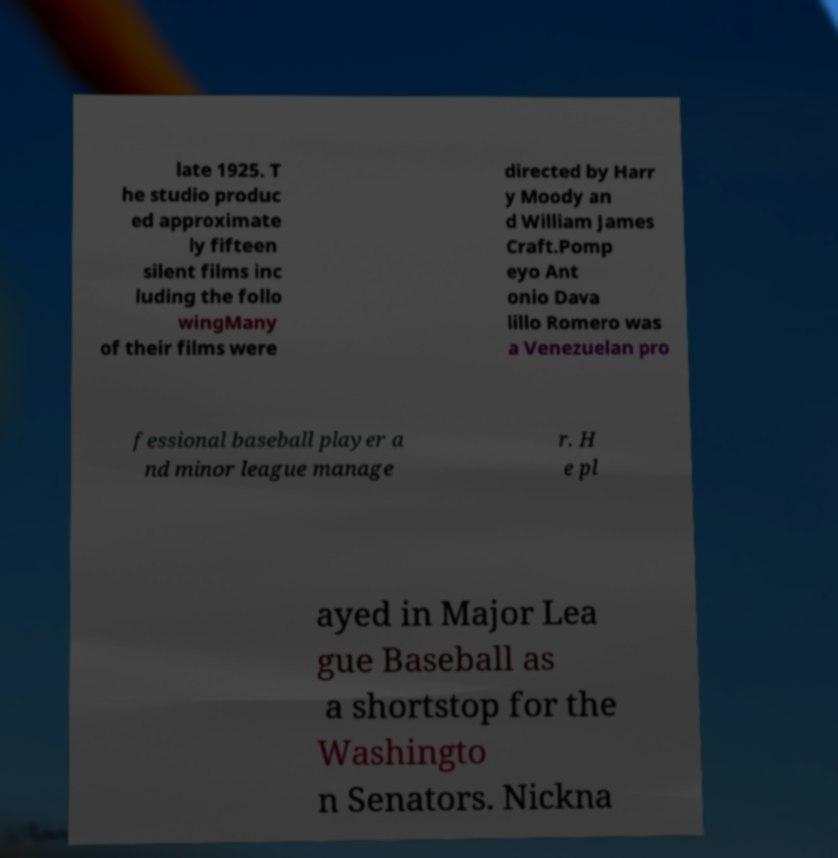Can you accurately transcribe the text from the provided image for me? late 1925. T he studio produc ed approximate ly fifteen silent films inc luding the follo wingMany of their films were directed by Harr y Moody an d William James Craft.Pomp eyo Ant onio Dava lillo Romero was a Venezuelan pro fessional baseball player a nd minor league manage r. H e pl ayed in Major Lea gue Baseball as a shortstop for the Washingto n Senators. Nickna 